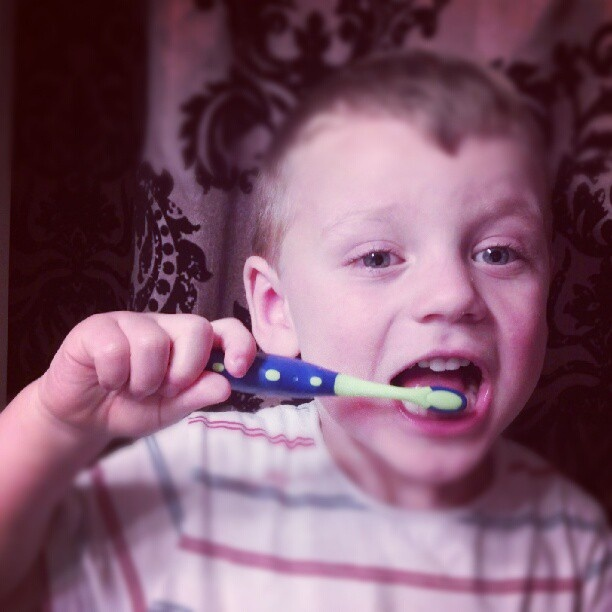Describe the objects in this image and their specific colors. I can see people in black, pink, violet, and purple tones and toothbrush in black, beige, navy, blue, and darkblue tones in this image. 